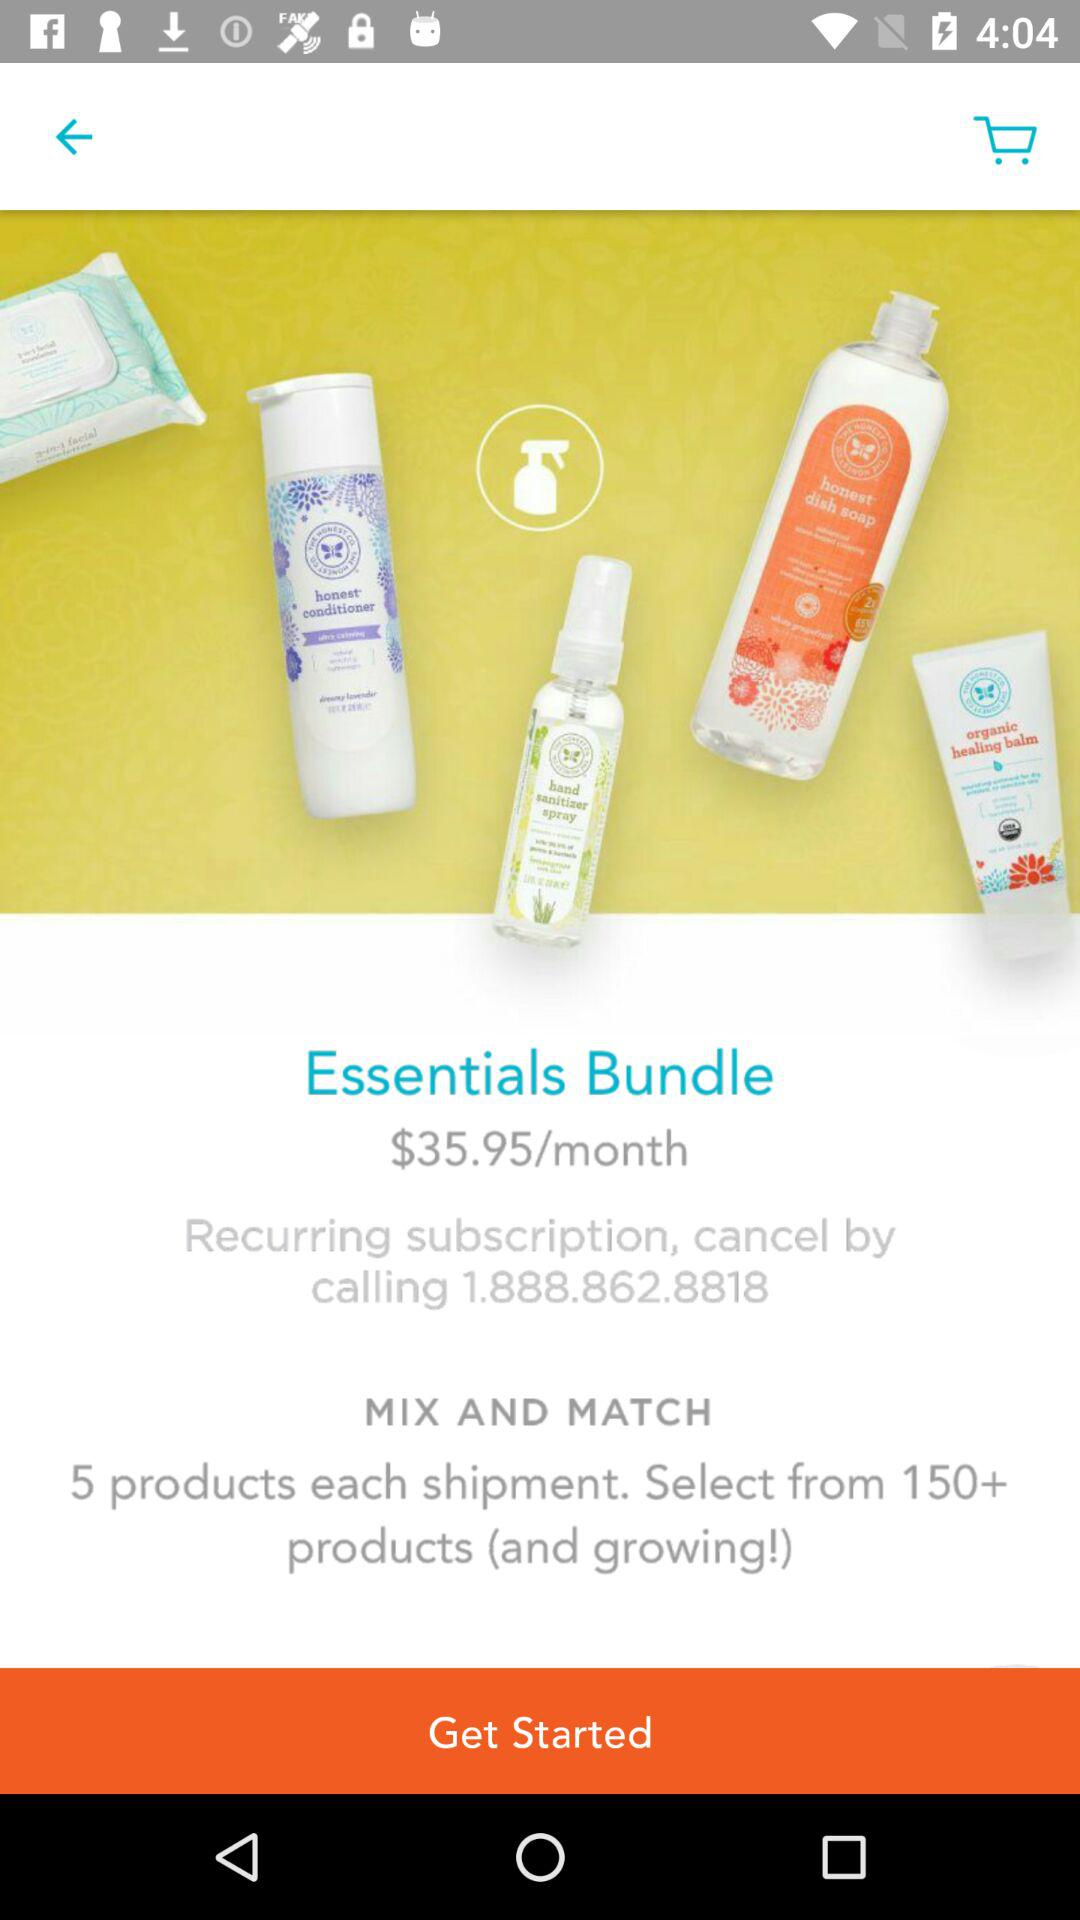How many products do I get in each shipment?
Answer the question using a single word or phrase. 5 